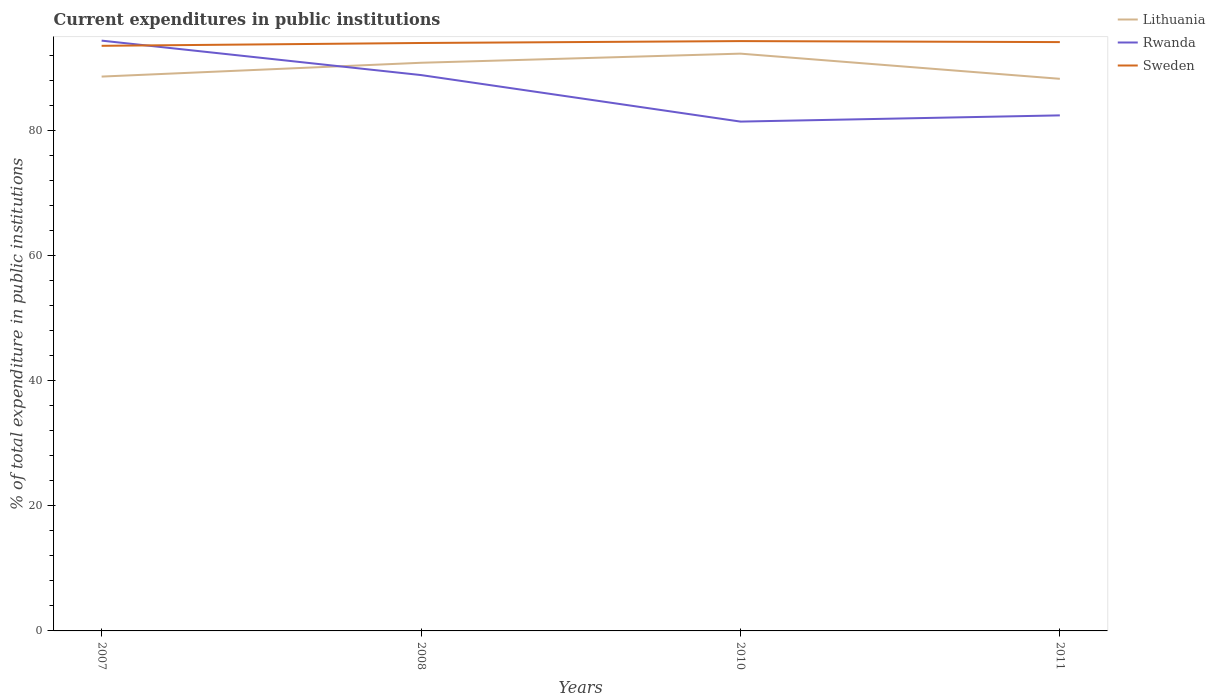How many different coloured lines are there?
Your answer should be very brief. 3. Does the line corresponding to Rwanda intersect with the line corresponding to Sweden?
Provide a succinct answer. Yes. Across all years, what is the maximum current expenditures in public institutions in Sweden?
Make the answer very short. 93.62. In which year was the current expenditures in public institutions in Sweden maximum?
Provide a succinct answer. 2007. What is the total current expenditures in public institutions in Rwanda in the graph?
Offer a terse response. 6.45. What is the difference between the highest and the second highest current expenditures in public institutions in Lithuania?
Your answer should be compact. 4.03. What is the difference between the highest and the lowest current expenditures in public institutions in Sweden?
Offer a very short reply. 3. Is the current expenditures in public institutions in Sweden strictly greater than the current expenditures in public institutions in Rwanda over the years?
Provide a succinct answer. No. What is the difference between two consecutive major ticks on the Y-axis?
Offer a very short reply. 20. Does the graph contain any zero values?
Give a very brief answer. No. What is the title of the graph?
Your answer should be very brief. Current expenditures in public institutions. What is the label or title of the Y-axis?
Your answer should be compact. % of total expenditure in public institutions. What is the % of total expenditure in public institutions in Lithuania in 2007?
Make the answer very short. 88.7. What is the % of total expenditure in public institutions in Rwanda in 2007?
Offer a terse response. 94.45. What is the % of total expenditure in public institutions of Sweden in 2007?
Ensure brevity in your answer.  93.62. What is the % of total expenditure in public institutions of Lithuania in 2008?
Provide a succinct answer. 90.91. What is the % of total expenditure in public institutions in Rwanda in 2008?
Your response must be concise. 88.94. What is the % of total expenditure in public institutions in Sweden in 2008?
Your response must be concise. 94.08. What is the % of total expenditure in public institutions of Lithuania in 2010?
Give a very brief answer. 92.37. What is the % of total expenditure in public institutions of Rwanda in 2010?
Your answer should be very brief. 81.5. What is the % of total expenditure in public institutions in Sweden in 2010?
Provide a succinct answer. 94.38. What is the % of total expenditure in public institutions in Lithuania in 2011?
Keep it short and to the point. 88.34. What is the % of total expenditure in public institutions in Rwanda in 2011?
Your answer should be compact. 82.49. What is the % of total expenditure in public institutions in Sweden in 2011?
Give a very brief answer. 94.22. Across all years, what is the maximum % of total expenditure in public institutions of Lithuania?
Give a very brief answer. 92.37. Across all years, what is the maximum % of total expenditure in public institutions of Rwanda?
Your response must be concise. 94.45. Across all years, what is the maximum % of total expenditure in public institutions of Sweden?
Provide a succinct answer. 94.38. Across all years, what is the minimum % of total expenditure in public institutions in Lithuania?
Provide a succinct answer. 88.34. Across all years, what is the minimum % of total expenditure in public institutions of Rwanda?
Your answer should be very brief. 81.5. Across all years, what is the minimum % of total expenditure in public institutions in Sweden?
Your answer should be very brief. 93.62. What is the total % of total expenditure in public institutions of Lithuania in the graph?
Ensure brevity in your answer.  360.33. What is the total % of total expenditure in public institutions of Rwanda in the graph?
Ensure brevity in your answer.  347.39. What is the total % of total expenditure in public institutions in Sweden in the graph?
Your answer should be very brief. 376.3. What is the difference between the % of total expenditure in public institutions in Lithuania in 2007 and that in 2008?
Make the answer very short. -2.21. What is the difference between the % of total expenditure in public institutions in Rwanda in 2007 and that in 2008?
Your answer should be very brief. 5.51. What is the difference between the % of total expenditure in public institutions of Sweden in 2007 and that in 2008?
Provide a short and direct response. -0.45. What is the difference between the % of total expenditure in public institutions of Lithuania in 2007 and that in 2010?
Your answer should be very brief. -3.67. What is the difference between the % of total expenditure in public institutions of Rwanda in 2007 and that in 2010?
Offer a terse response. 12.96. What is the difference between the % of total expenditure in public institutions in Sweden in 2007 and that in 2010?
Make the answer very short. -0.76. What is the difference between the % of total expenditure in public institutions of Lithuania in 2007 and that in 2011?
Your answer should be compact. 0.36. What is the difference between the % of total expenditure in public institutions of Rwanda in 2007 and that in 2011?
Provide a succinct answer. 11.96. What is the difference between the % of total expenditure in public institutions of Sweden in 2007 and that in 2011?
Make the answer very short. -0.59. What is the difference between the % of total expenditure in public institutions of Lithuania in 2008 and that in 2010?
Make the answer very short. -1.46. What is the difference between the % of total expenditure in public institutions of Rwanda in 2008 and that in 2010?
Your response must be concise. 7.44. What is the difference between the % of total expenditure in public institutions in Sweden in 2008 and that in 2010?
Your answer should be compact. -0.3. What is the difference between the % of total expenditure in public institutions of Lithuania in 2008 and that in 2011?
Offer a very short reply. 2.57. What is the difference between the % of total expenditure in public institutions of Rwanda in 2008 and that in 2011?
Provide a short and direct response. 6.45. What is the difference between the % of total expenditure in public institutions of Sweden in 2008 and that in 2011?
Your response must be concise. -0.14. What is the difference between the % of total expenditure in public institutions of Lithuania in 2010 and that in 2011?
Provide a succinct answer. 4.03. What is the difference between the % of total expenditure in public institutions of Rwanda in 2010 and that in 2011?
Your answer should be compact. -0.99. What is the difference between the % of total expenditure in public institutions of Sweden in 2010 and that in 2011?
Provide a short and direct response. 0.16. What is the difference between the % of total expenditure in public institutions of Lithuania in 2007 and the % of total expenditure in public institutions of Rwanda in 2008?
Your answer should be very brief. -0.24. What is the difference between the % of total expenditure in public institutions of Lithuania in 2007 and the % of total expenditure in public institutions of Sweden in 2008?
Give a very brief answer. -5.38. What is the difference between the % of total expenditure in public institutions in Rwanda in 2007 and the % of total expenditure in public institutions in Sweden in 2008?
Your answer should be very brief. 0.38. What is the difference between the % of total expenditure in public institutions in Lithuania in 2007 and the % of total expenditure in public institutions in Rwanda in 2010?
Your response must be concise. 7.2. What is the difference between the % of total expenditure in public institutions of Lithuania in 2007 and the % of total expenditure in public institutions of Sweden in 2010?
Your response must be concise. -5.68. What is the difference between the % of total expenditure in public institutions of Rwanda in 2007 and the % of total expenditure in public institutions of Sweden in 2010?
Your answer should be very brief. 0.08. What is the difference between the % of total expenditure in public institutions in Lithuania in 2007 and the % of total expenditure in public institutions in Rwanda in 2011?
Make the answer very short. 6.21. What is the difference between the % of total expenditure in public institutions in Lithuania in 2007 and the % of total expenditure in public institutions in Sweden in 2011?
Provide a succinct answer. -5.52. What is the difference between the % of total expenditure in public institutions of Rwanda in 2007 and the % of total expenditure in public institutions of Sweden in 2011?
Make the answer very short. 0.24. What is the difference between the % of total expenditure in public institutions of Lithuania in 2008 and the % of total expenditure in public institutions of Rwanda in 2010?
Offer a very short reply. 9.41. What is the difference between the % of total expenditure in public institutions in Lithuania in 2008 and the % of total expenditure in public institutions in Sweden in 2010?
Offer a terse response. -3.47. What is the difference between the % of total expenditure in public institutions of Rwanda in 2008 and the % of total expenditure in public institutions of Sweden in 2010?
Your answer should be compact. -5.44. What is the difference between the % of total expenditure in public institutions in Lithuania in 2008 and the % of total expenditure in public institutions in Rwanda in 2011?
Keep it short and to the point. 8.42. What is the difference between the % of total expenditure in public institutions of Lithuania in 2008 and the % of total expenditure in public institutions of Sweden in 2011?
Offer a terse response. -3.31. What is the difference between the % of total expenditure in public institutions of Rwanda in 2008 and the % of total expenditure in public institutions of Sweden in 2011?
Keep it short and to the point. -5.28. What is the difference between the % of total expenditure in public institutions in Lithuania in 2010 and the % of total expenditure in public institutions in Rwanda in 2011?
Keep it short and to the point. 9.88. What is the difference between the % of total expenditure in public institutions in Lithuania in 2010 and the % of total expenditure in public institutions in Sweden in 2011?
Ensure brevity in your answer.  -1.85. What is the difference between the % of total expenditure in public institutions in Rwanda in 2010 and the % of total expenditure in public institutions in Sweden in 2011?
Ensure brevity in your answer.  -12.72. What is the average % of total expenditure in public institutions in Lithuania per year?
Your answer should be very brief. 90.08. What is the average % of total expenditure in public institutions in Rwanda per year?
Your answer should be very brief. 86.85. What is the average % of total expenditure in public institutions of Sweden per year?
Provide a succinct answer. 94.07. In the year 2007, what is the difference between the % of total expenditure in public institutions in Lithuania and % of total expenditure in public institutions in Rwanda?
Provide a short and direct response. -5.75. In the year 2007, what is the difference between the % of total expenditure in public institutions in Lithuania and % of total expenditure in public institutions in Sweden?
Provide a short and direct response. -4.92. In the year 2007, what is the difference between the % of total expenditure in public institutions of Rwanda and % of total expenditure in public institutions of Sweden?
Your response must be concise. 0.83. In the year 2008, what is the difference between the % of total expenditure in public institutions in Lithuania and % of total expenditure in public institutions in Rwanda?
Offer a very short reply. 1.97. In the year 2008, what is the difference between the % of total expenditure in public institutions of Lithuania and % of total expenditure in public institutions of Sweden?
Your answer should be very brief. -3.17. In the year 2008, what is the difference between the % of total expenditure in public institutions of Rwanda and % of total expenditure in public institutions of Sweden?
Ensure brevity in your answer.  -5.13. In the year 2010, what is the difference between the % of total expenditure in public institutions in Lithuania and % of total expenditure in public institutions in Rwanda?
Give a very brief answer. 10.87. In the year 2010, what is the difference between the % of total expenditure in public institutions of Lithuania and % of total expenditure in public institutions of Sweden?
Keep it short and to the point. -2.01. In the year 2010, what is the difference between the % of total expenditure in public institutions of Rwanda and % of total expenditure in public institutions of Sweden?
Provide a short and direct response. -12.88. In the year 2011, what is the difference between the % of total expenditure in public institutions of Lithuania and % of total expenditure in public institutions of Rwanda?
Ensure brevity in your answer.  5.85. In the year 2011, what is the difference between the % of total expenditure in public institutions of Lithuania and % of total expenditure in public institutions of Sweden?
Keep it short and to the point. -5.87. In the year 2011, what is the difference between the % of total expenditure in public institutions of Rwanda and % of total expenditure in public institutions of Sweden?
Provide a short and direct response. -11.72. What is the ratio of the % of total expenditure in public institutions of Lithuania in 2007 to that in 2008?
Make the answer very short. 0.98. What is the ratio of the % of total expenditure in public institutions in Rwanda in 2007 to that in 2008?
Give a very brief answer. 1.06. What is the ratio of the % of total expenditure in public institutions in Lithuania in 2007 to that in 2010?
Ensure brevity in your answer.  0.96. What is the ratio of the % of total expenditure in public institutions of Rwanda in 2007 to that in 2010?
Offer a terse response. 1.16. What is the ratio of the % of total expenditure in public institutions of Rwanda in 2007 to that in 2011?
Provide a short and direct response. 1.15. What is the ratio of the % of total expenditure in public institutions in Lithuania in 2008 to that in 2010?
Your answer should be compact. 0.98. What is the ratio of the % of total expenditure in public institutions of Rwanda in 2008 to that in 2010?
Your answer should be very brief. 1.09. What is the ratio of the % of total expenditure in public institutions of Lithuania in 2008 to that in 2011?
Provide a short and direct response. 1.03. What is the ratio of the % of total expenditure in public institutions of Rwanda in 2008 to that in 2011?
Your answer should be compact. 1.08. What is the ratio of the % of total expenditure in public institutions in Lithuania in 2010 to that in 2011?
Your answer should be compact. 1.05. What is the ratio of the % of total expenditure in public institutions of Rwanda in 2010 to that in 2011?
Provide a short and direct response. 0.99. What is the ratio of the % of total expenditure in public institutions in Sweden in 2010 to that in 2011?
Keep it short and to the point. 1. What is the difference between the highest and the second highest % of total expenditure in public institutions of Lithuania?
Keep it short and to the point. 1.46. What is the difference between the highest and the second highest % of total expenditure in public institutions in Rwanda?
Ensure brevity in your answer.  5.51. What is the difference between the highest and the second highest % of total expenditure in public institutions in Sweden?
Ensure brevity in your answer.  0.16. What is the difference between the highest and the lowest % of total expenditure in public institutions of Lithuania?
Keep it short and to the point. 4.03. What is the difference between the highest and the lowest % of total expenditure in public institutions in Rwanda?
Keep it short and to the point. 12.96. What is the difference between the highest and the lowest % of total expenditure in public institutions in Sweden?
Your answer should be compact. 0.76. 